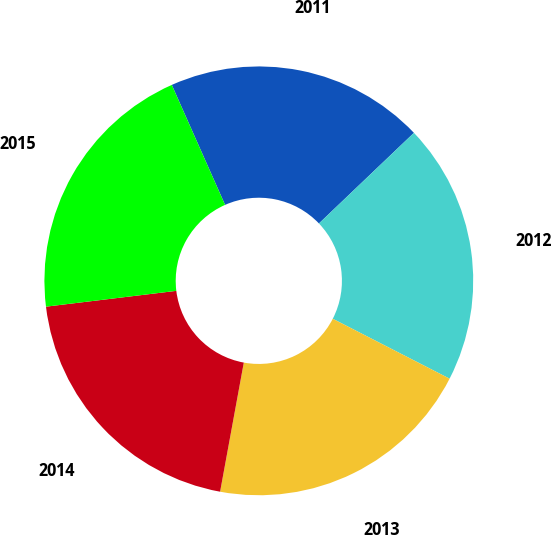<chart> <loc_0><loc_0><loc_500><loc_500><pie_chart><fcel>2011<fcel>2012<fcel>2013<fcel>2014<fcel>2015<nl><fcel>19.53%<fcel>19.67%<fcel>20.35%<fcel>20.19%<fcel>20.27%<nl></chart> 